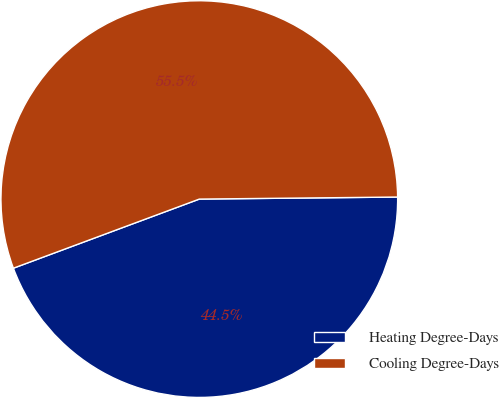Convert chart to OTSL. <chart><loc_0><loc_0><loc_500><loc_500><pie_chart><fcel>Heating Degree-Days<fcel>Cooling Degree-Days<nl><fcel>44.5%<fcel>55.5%<nl></chart> 